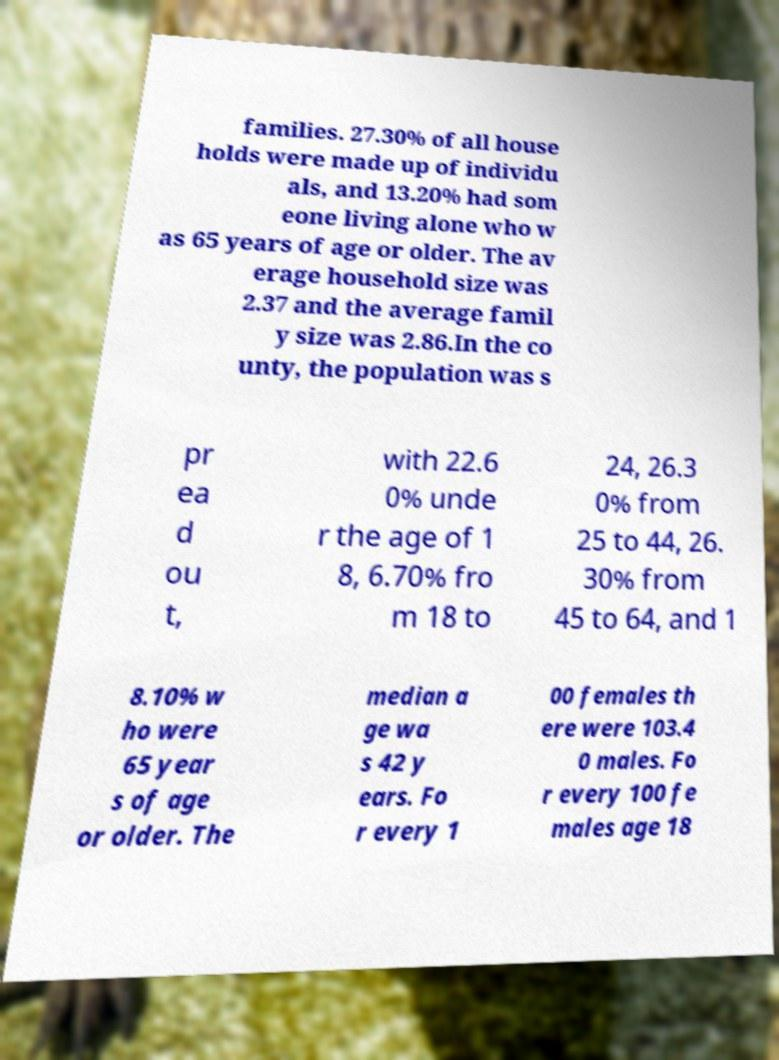Can you read and provide the text displayed in the image?This photo seems to have some interesting text. Can you extract and type it out for me? families. 27.30% of all house holds were made up of individu als, and 13.20% had som eone living alone who w as 65 years of age or older. The av erage household size was 2.37 and the average famil y size was 2.86.In the co unty, the population was s pr ea d ou t, with 22.6 0% unde r the age of 1 8, 6.70% fro m 18 to 24, 26.3 0% from 25 to 44, 26. 30% from 45 to 64, and 1 8.10% w ho were 65 year s of age or older. The median a ge wa s 42 y ears. Fo r every 1 00 females th ere were 103.4 0 males. Fo r every 100 fe males age 18 